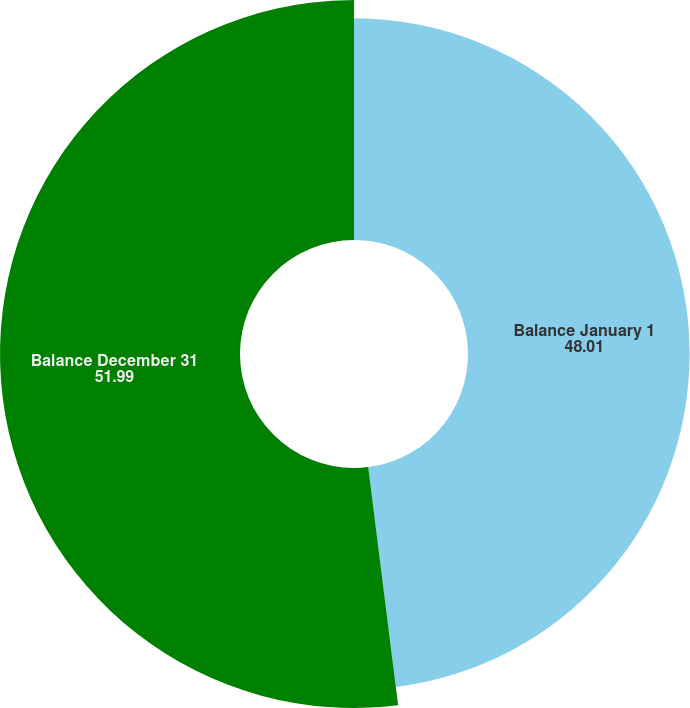<chart> <loc_0><loc_0><loc_500><loc_500><pie_chart><fcel>Balance January 1<fcel>Balance December 31<nl><fcel>48.01%<fcel>51.99%<nl></chart> 